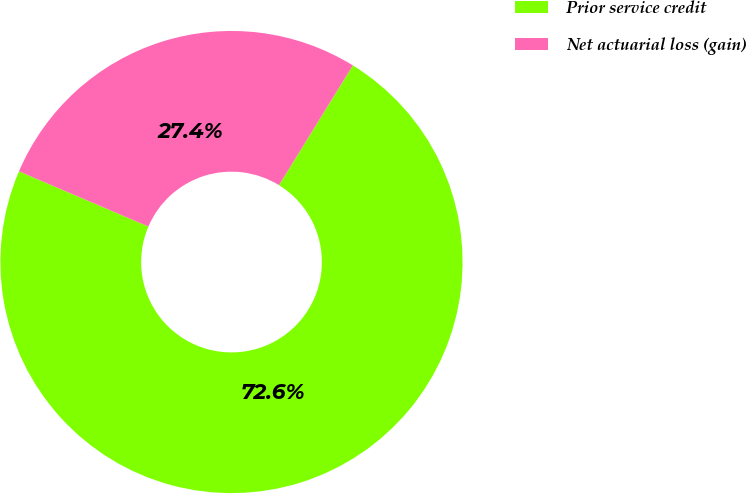Convert chart to OTSL. <chart><loc_0><loc_0><loc_500><loc_500><pie_chart><fcel>Prior service credit<fcel>Net actuarial loss (gain)<nl><fcel>72.62%<fcel>27.38%<nl></chart> 